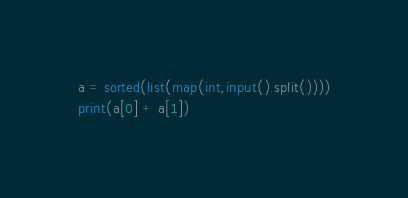Convert code to text. <code><loc_0><loc_0><loc_500><loc_500><_Python_>a = sorted(list(map(int,input().split())))
print(a[0] + a[1])</code> 